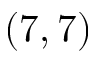Convert formula to latex. <formula><loc_0><loc_0><loc_500><loc_500>( 7 , 7 )</formula> 